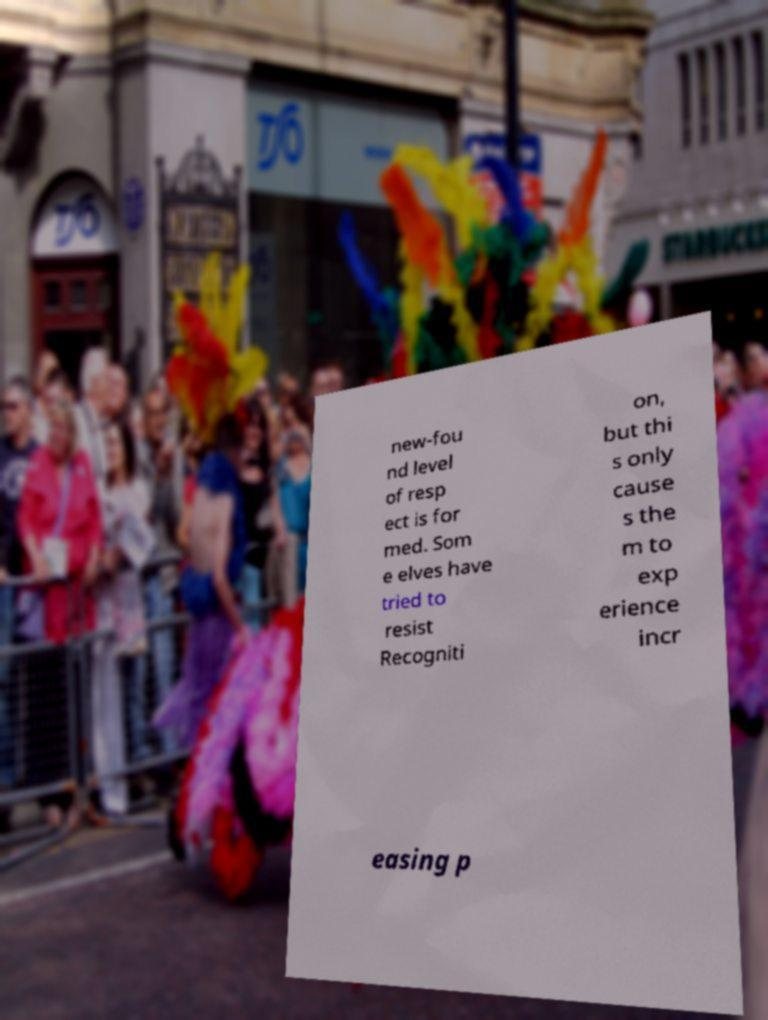Could you assist in decoding the text presented in this image and type it out clearly? new-fou nd level of resp ect is for med. Som e elves have tried to resist Recogniti on, but thi s only cause s the m to exp erience incr easing p 